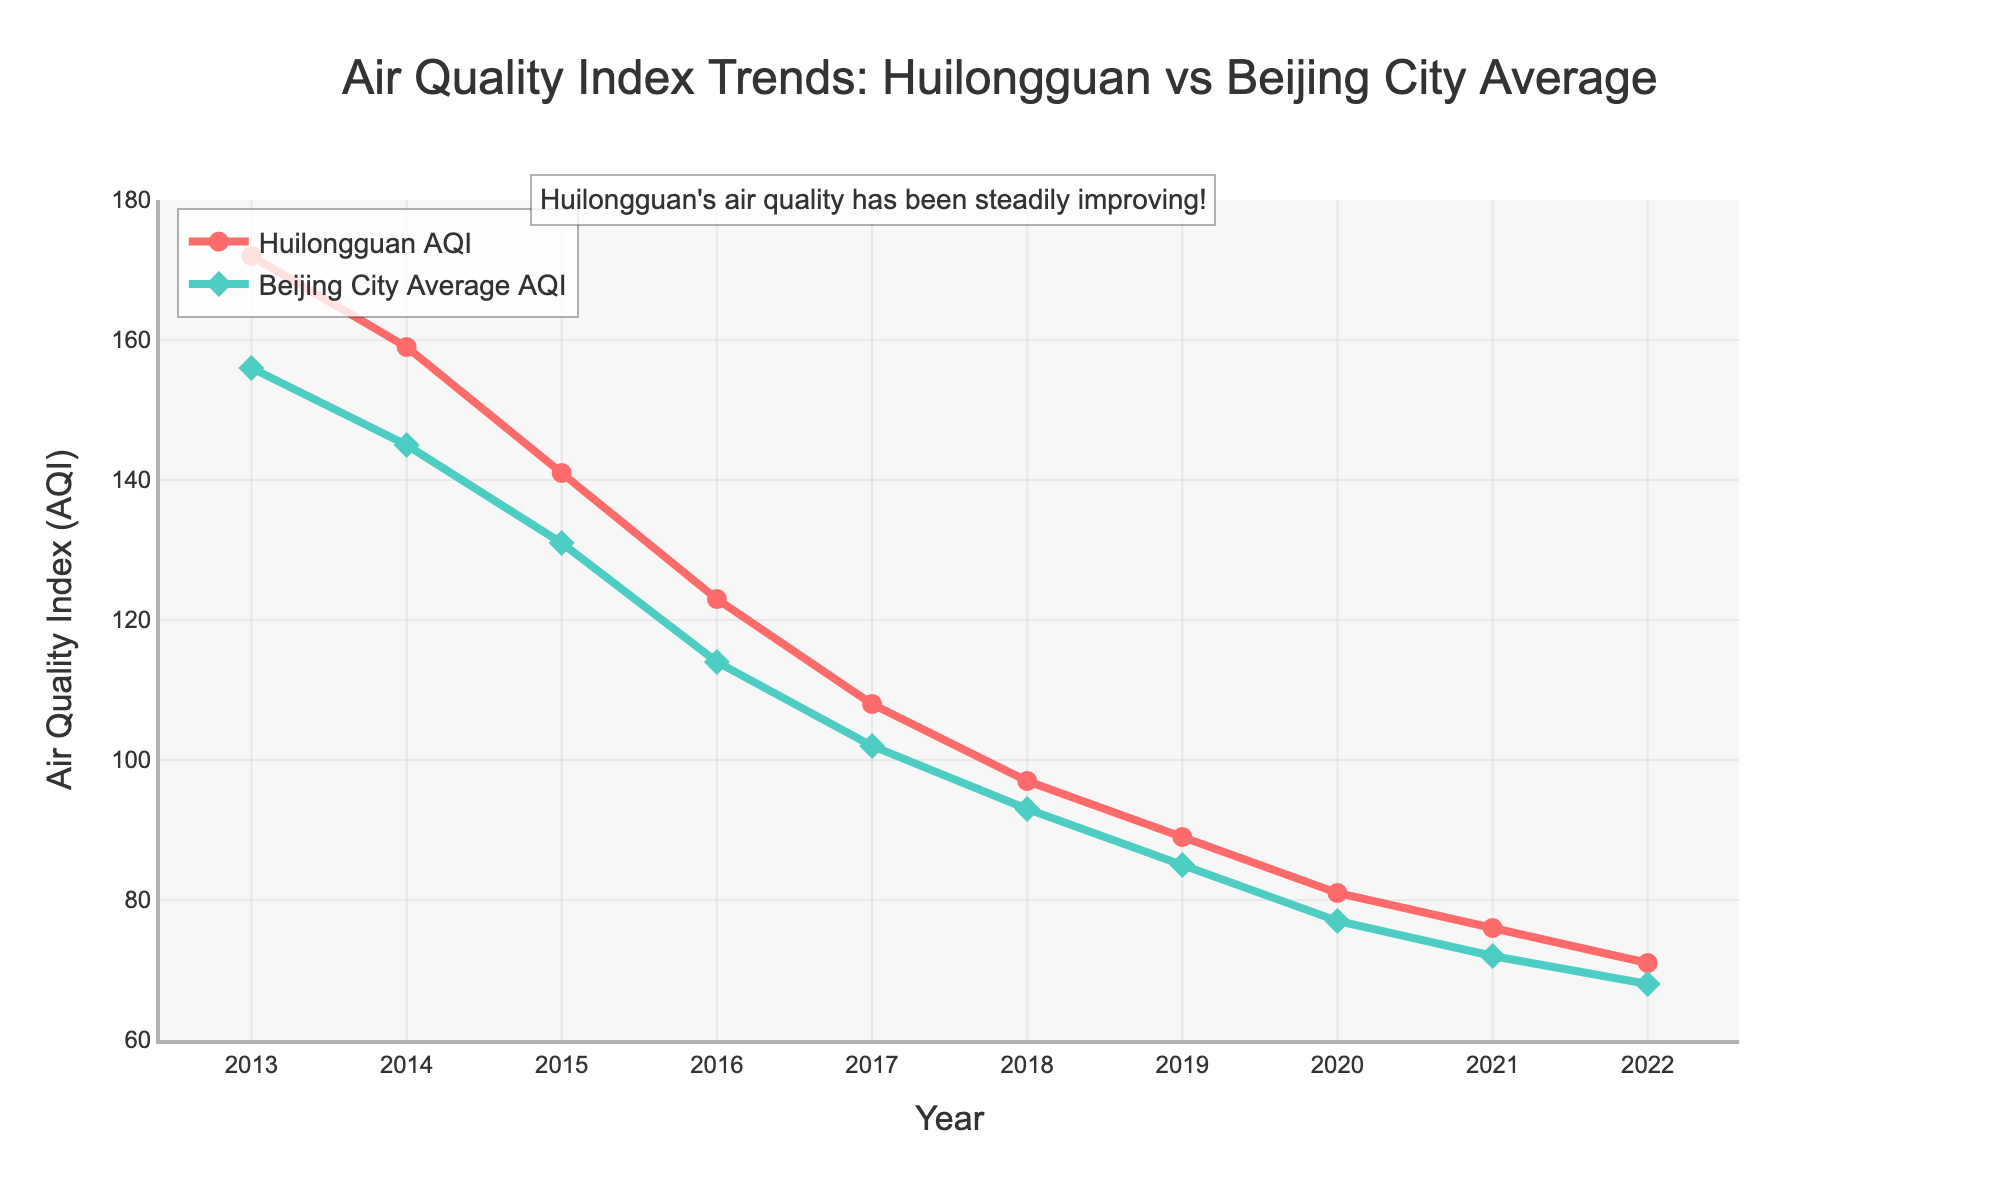What's the trend in Huilongguan's AQI over the decade? To determine the trend, look at the line labeled "Huilongguan AQI". Over the decade, the AQI values for Huilongguan show a consistent downward trend from 172 in 2013 to 71 in 2022.
Answer: Downward In which year did Huilongguan AQI first drop below 100? Examine the line graph for "Huilongguan AQI" and identify the year where the AQI value first falls below 100. This occurs in 2018 when the AQI reached 97.
Answer: 2018 How does the AQI in Huilongguan in 2018 compare to the Beijing City Average AQI in the same year? Identify the AQI values from the lines for both Huilongguan and Beijing City Average in 2018. Huilongguan AQI is 97, whereas Beijing City Average AQI is 93. Comparatively, the Huilongguan AQI is higher.
Answer: Higher Which year shows the smallest difference between Huilongguan AQI and Beijing City Average AQI, and what is the difference? Calculate the differences between the two AQI values for each year and identify the year with the smallest difference. The difference between the AQI values is smallest in 2017, where Huilongguan AQI is 108 and Beijing City Average AQI is 102, yielding a difference of 6.
Answer: 2017, 6 What is the average AQI for Huilongguan over the decade? Sum up the AQI values for Huilongguan from 2013 to 2022 (172 + 159 + 141 + 123 + 108 + 97 + 89 + 81 + 76 + 71) and divide by 10 to find the average. The sum is 1117, so the average is 1117 / 10.
Answer: 111.7 In which year is the gap between Huilongguan AQI and Beijing City Average AQI the largest, and what is the gap? Calculate the gap (difference) between Huilongguan AQI and Beijing City Average AQI for each year and determine the year with the largest gap. The gap is largest in 2013, where the AQI values are 172 for Huilongguan and 156 for Beijing, yielding a gap of 16.
Answer: 2013, 16 What is the percentage decrease in Huilongguan AQI from 2013 to 2022? Calculate the percentage decrease using the formula: [(AQI in 2013 - AQI in 2022) / AQI in 2013] * 100. Substituting the values: [(172 - 71) / 172] * 100 = 58.72%.
Answer: 58.72% Which AQI value is lower in 2020: Huilongguan or Beijing City Average? Compare the AQI values in 2020 for Huilongguan (81) and Beijing City Average (77) from the line graph. The Beijing City Average AQI is lower.
Answer: Beijing City Average 